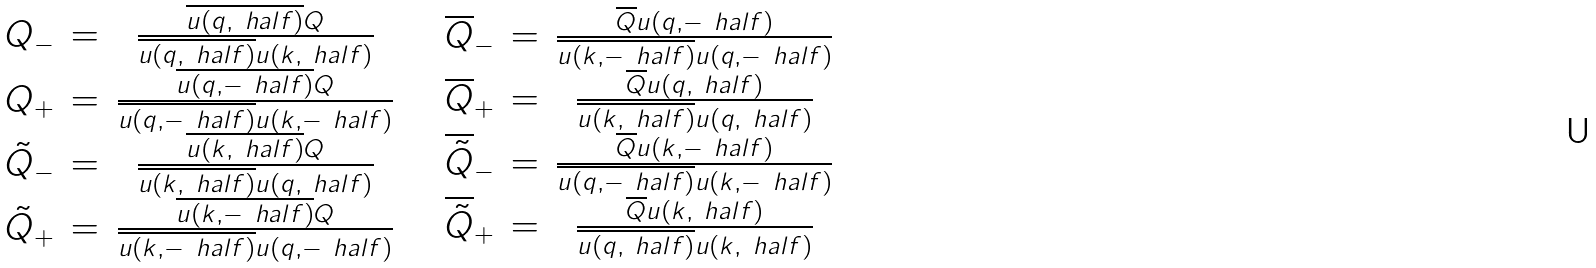Convert formula to latex. <formula><loc_0><loc_0><loc_500><loc_500>\begin{array} { c c c } Q _ { - } & = & \frac { \overline { u ( q , \ h a l f ) } Q } { \overline { u ( q , \ h a l f ) } u ( k , \ h a l f ) } \\ Q _ { + } & = & \frac { \overline { u ( q , - \ h a l f ) } Q } { \overline { u ( q , - \ h a l f ) } u ( k , - \ h a l f ) } \\ \tilde { Q } _ { - } & = & \frac { \overline { u ( k , \ h a l f ) } Q } { \overline { u ( k , \ h a l f ) } u ( q , \ h a l f ) } \\ \tilde { Q } _ { + } & = & \frac { \overline { u ( k , - \ h a l f ) } Q } { \overline { u ( k , - \ h a l f ) } u ( q , - \ h a l f ) } \end{array} \quad \begin{array} { c c c } \overline { Q } _ { - } & = & \frac { \overline { Q } u ( q , - \ h a l f ) } { \overline { u ( k , - \ h a l f ) } u ( q , - \ h a l f ) } \\ \overline { Q } _ { + } & = & \frac { \overline { Q } u ( q , \ h a l f ) } { \overline { u ( k , \ h a l f ) } u ( q , \ h a l f ) } \\ \overline { \tilde { Q } } _ { - } & = & \frac { \overline { Q } u ( k , - \ h a l f ) } { \overline { u ( q , - \ h a l f ) } u ( k , - \ h a l f ) } \\ \overline { \tilde { Q } } _ { + } & = & \frac { \overline { Q } u ( k , \ h a l f ) } { \overline { u ( q , \ h a l f ) } u ( k , \ h a l f ) } \end{array}</formula> 